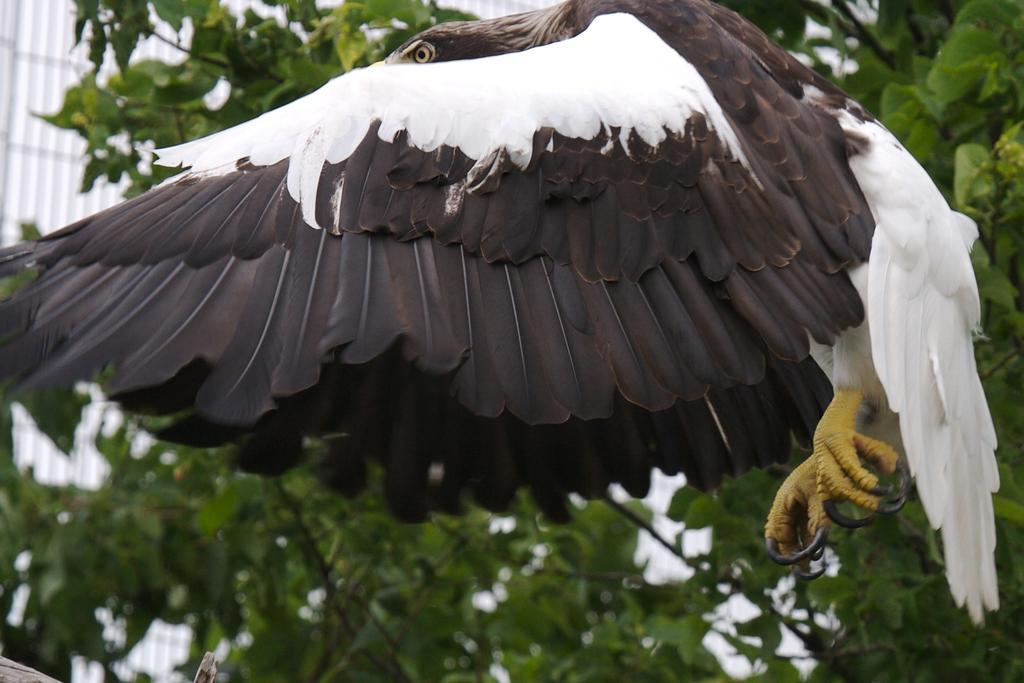What animal is the main subject of the image? There is an eagle in the image. What can be seen in the background of the image? There are trees and buildings in the background of the image. What type of cup is being used by the eagle in the image? There is no cup present in the image; it features an eagle and a background with trees and buildings. 